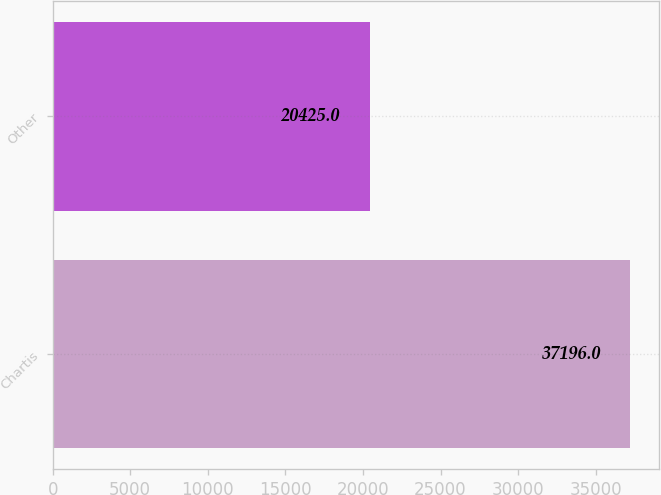Convert chart. <chart><loc_0><loc_0><loc_500><loc_500><bar_chart><fcel>Chartis<fcel>Other<nl><fcel>37196<fcel>20425<nl></chart> 